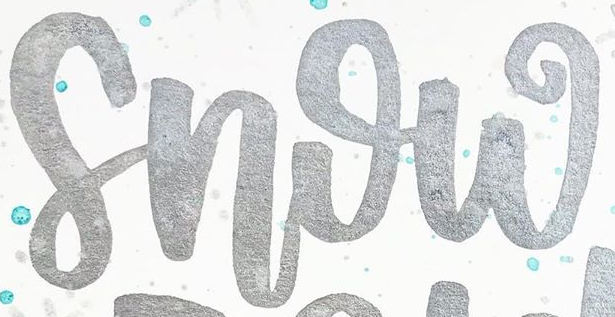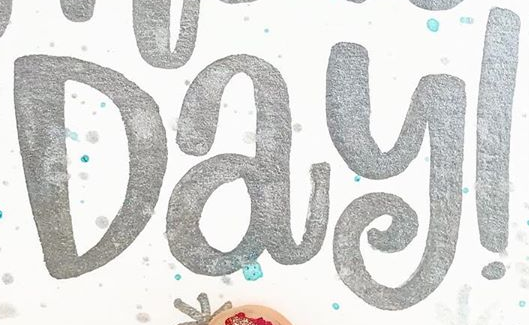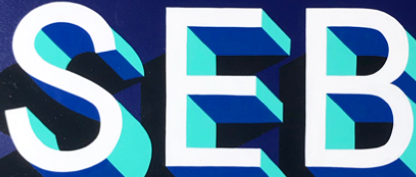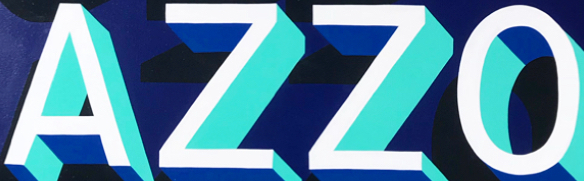Read the text from these images in sequence, separated by a semicolon. Snow; Day!; SEB; AZZO 